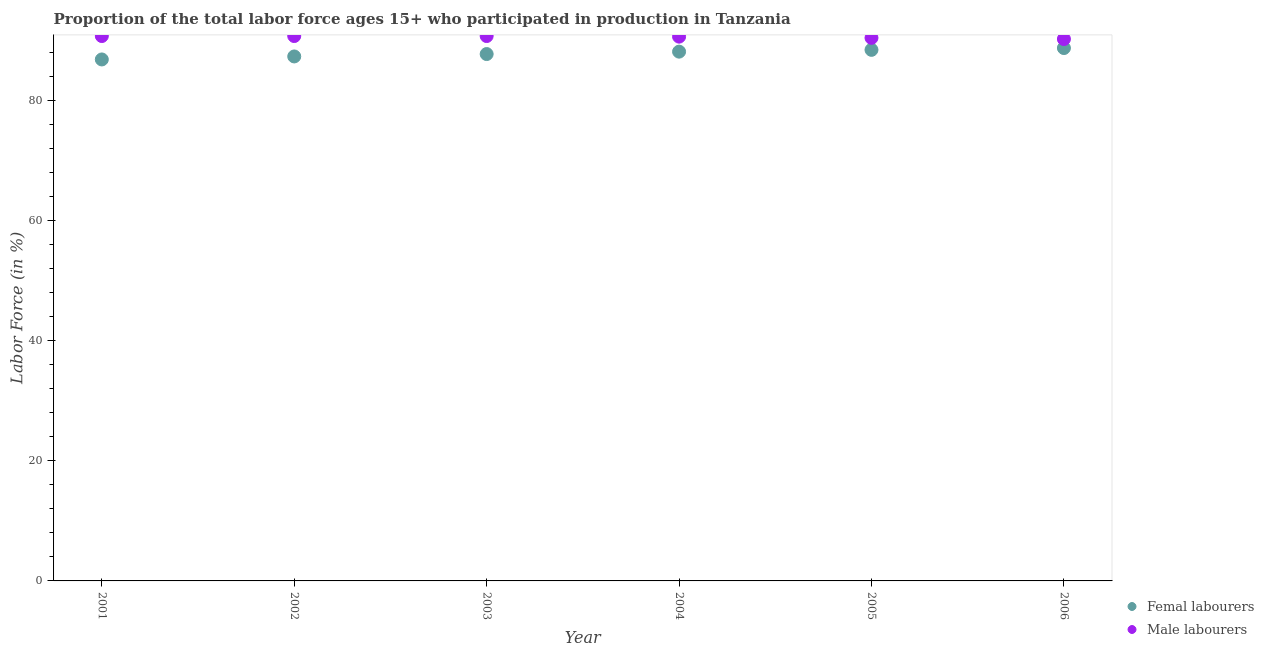Is the number of dotlines equal to the number of legend labels?
Make the answer very short. Yes. What is the percentage of female labor force in 2006?
Give a very brief answer. 88.8. Across all years, what is the maximum percentage of female labor force?
Your answer should be compact. 88.8. Across all years, what is the minimum percentage of male labour force?
Ensure brevity in your answer.  90.3. In which year was the percentage of female labor force minimum?
Provide a short and direct response. 2001. What is the total percentage of female labor force in the graph?
Your answer should be compact. 527.6. What is the difference between the percentage of female labor force in 2003 and that in 2004?
Give a very brief answer. -0.4. What is the difference between the percentage of female labor force in 2002 and the percentage of male labour force in 2005?
Provide a succinct answer. -3.1. What is the average percentage of female labor force per year?
Your response must be concise. 87.93. In the year 2003, what is the difference between the percentage of male labour force and percentage of female labor force?
Your answer should be compact. 3. In how many years, is the percentage of male labour force greater than 48 %?
Your answer should be very brief. 6. What is the ratio of the percentage of male labour force in 2002 to that in 2005?
Your answer should be very brief. 1. Is the percentage of female labor force in 2004 less than that in 2006?
Provide a short and direct response. Yes. Is the difference between the percentage of female labor force in 2004 and 2006 greater than the difference between the percentage of male labour force in 2004 and 2006?
Your response must be concise. No. What is the difference between the highest and the lowest percentage of female labor force?
Your response must be concise. 1.9. Does the percentage of female labor force monotonically increase over the years?
Your answer should be compact. Yes. Is the percentage of female labor force strictly greater than the percentage of male labour force over the years?
Offer a very short reply. No. How many dotlines are there?
Make the answer very short. 2. What is the difference between two consecutive major ticks on the Y-axis?
Your answer should be compact. 20. Does the graph contain grids?
Your response must be concise. No. How many legend labels are there?
Your answer should be very brief. 2. How are the legend labels stacked?
Provide a short and direct response. Vertical. What is the title of the graph?
Provide a short and direct response. Proportion of the total labor force ages 15+ who participated in production in Tanzania. Does "Banks" appear as one of the legend labels in the graph?
Your response must be concise. No. What is the Labor Force (in %) in Femal labourers in 2001?
Your response must be concise. 86.9. What is the Labor Force (in %) of Male labourers in 2001?
Your answer should be compact. 90.8. What is the Labor Force (in %) of Femal labourers in 2002?
Provide a succinct answer. 87.4. What is the Labor Force (in %) of Male labourers in 2002?
Offer a terse response. 90.8. What is the Labor Force (in %) of Femal labourers in 2003?
Ensure brevity in your answer.  87.8. What is the Labor Force (in %) in Male labourers in 2003?
Offer a very short reply. 90.8. What is the Labor Force (in %) in Femal labourers in 2004?
Offer a very short reply. 88.2. What is the Labor Force (in %) of Male labourers in 2004?
Offer a terse response. 90.7. What is the Labor Force (in %) of Femal labourers in 2005?
Offer a terse response. 88.5. What is the Labor Force (in %) of Male labourers in 2005?
Provide a succinct answer. 90.5. What is the Labor Force (in %) of Femal labourers in 2006?
Your answer should be compact. 88.8. What is the Labor Force (in %) in Male labourers in 2006?
Your response must be concise. 90.3. Across all years, what is the maximum Labor Force (in %) in Femal labourers?
Keep it short and to the point. 88.8. Across all years, what is the maximum Labor Force (in %) in Male labourers?
Keep it short and to the point. 90.8. Across all years, what is the minimum Labor Force (in %) in Femal labourers?
Your answer should be compact. 86.9. Across all years, what is the minimum Labor Force (in %) of Male labourers?
Your response must be concise. 90.3. What is the total Labor Force (in %) in Femal labourers in the graph?
Provide a succinct answer. 527.6. What is the total Labor Force (in %) of Male labourers in the graph?
Offer a very short reply. 543.9. What is the difference between the Labor Force (in %) in Male labourers in 2001 and that in 2002?
Your response must be concise. 0. What is the difference between the Labor Force (in %) in Femal labourers in 2001 and that in 2003?
Keep it short and to the point. -0.9. What is the difference between the Labor Force (in %) of Male labourers in 2001 and that in 2003?
Your answer should be very brief. 0. What is the difference between the Labor Force (in %) of Femal labourers in 2001 and that in 2004?
Give a very brief answer. -1.3. What is the difference between the Labor Force (in %) in Male labourers in 2001 and that in 2004?
Your answer should be very brief. 0.1. What is the difference between the Labor Force (in %) in Male labourers in 2001 and that in 2005?
Keep it short and to the point. 0.3. What is the difference between the Labor Force (in %) in Femal labourers in 2001 and that in 2006?
Provide a short and direct response. -1.9. What is the difference between the Labor Force (in %) of Male labourers in 2003 and that in 2004?
Your response must be concise. 0.1. What is the difference between the Labor Force (in %) in Male labourers in 2003 and that in 2005?
Ensure brevity in your answer.  0.3. What is the difference between the Labor Force (in %) in Femal labourers in 2003 and that in 2006?
Your answer should be compact. -1. What is the difference between the Labor Force (in %) of Male labourers in 2003 and that in 2006?
Your answer should be very brief. 0.5. What is the difference between the Labor Force (in %) in Male labourers in 2004 and that in 2005?
Provide a succinct answer. 0.2. What is the difference between the Labor Force (in %) of Femal labourers in 2001 and the Labor Force (in %) of Male labourers in 2002?
Your response must be concise. -3.9. What is the difference between the Labor Force (in %) in Femal labourers in 2001 and the Labor Force (in %) in Male labourers in 2003?
Provide a succinct answer. -3.9. What is the difference between the Labor Force (in %) in Femal labourers in 2002 and the Labor Force (in %) in Male labourers in 2005?
Provide a short and direct response. -3.1. What is the difference between the Labor Force (in %) of Femal labourers in 2002 and the Labor Force (in %) of Male labourers in 2006?
Provide a succinct answer. -2.9. What is the difference between the Labor Force (in %) in Femal labourers in 2004 and the Labor Force (in %) in Male labourers in 2005?
Your answer should be compact. -2.3. What is the difference between the Labor Force (in %) of Femal labourers in 2004 and the Labor Force (in %) of Male labourers in 2006?
Offer a very short reply. -2.1. What is the average Labor Force (in %) of Femal labourers per year?
Provide a succinct answer. 87.93. What is the average Labor Force (in %) of Male labourers per year?
Make the answer very short. 90.65. In the year 2001, what is the difference between the Labor Force (in %) of Femal labourers and Labor Force (in %) of Male labourers?
Provide a short and direct response. -3.9. In the year 2002, what is the difference between the Labor Force (in %) in Femal labourers and Labor Force (in %) in Male labourers?
Provide a succinct answer. -3.4. In the year 2004, what is the difference between the Labor Force (in %) of Femal labourers and Labor Force (in %) of Male labourers?
Offer a very short reply. -2.5. In the year 2006, what is the difference between the Labor Force (in %) of Femal labourers and Labor Force (in %) of Male labourers?
Make the answer very short. -1.5. What is the ratio of the Labor Force (in %) of Femal labourers in 2001 to that in 2002?
Keep it short and to the point. 0.99. What is the ratio of the Labor Force (in %) of Male labourers in 2001 to that in 2003?
Provide a short and direct response. 1. What is the ratio of the Labor Force (in %) in Femal labourers in 2001 to that in 2005?
Your answer should be very brief. 0.98. What is the ratio of the Labor Force (in %) in Femal labourers in 2001 to that in 2006?
Keep it short and to the point. 0.98. What is the ratio of the Labor Force (in %) of Male labourers in 2001 to that in 2006?
Give a very brief answer. 1.01. What is the ratio of the Labor Force (in %) of Femal labourers in 2002 to that in 2004?
Give a very brief answer. 0.99. What is the ratio of the Labor Force (in %) of Femal labourers in 2002 to that in 2005?
Make the answer very short. 0.99. What is the ratio of the Labor Force (in %) in Male labourers in 2002 to that in 2005?
Offer a terse response. 1. What is the ratio of the Labor Force (in %) in Femal labourers in 2002 to that in 2006?
Keep it short and to the point. 0.98. What is the ratio of the Labor Force (in %) of Male labourers in 2002 to that in 2006?
Your answer should be compact. 1.01. What is the ratio of the Labor Force (in %) of Femal labourers in 2003 to that in 2004?
Your answer should be compact. 1. What is the ratio of the Labor Force (in %) in Male labourers in 2003 to that in 2004?
Your answer should be compact. 1. What is the ratio of the Labor Force (in %) in Femal labourers in 2003 to that in 2005?
Give a very brief answer. 0.99. What is the ratio of the Labor Force (in %) of Male labourers in 2003 to that in 2005?
Your answer should be very brief. 1. What is the ratio of the Labor Force (in %) in Femal labourers in 2003 to that in 2006?
Provide a short and direct response. 0.99. What is the ratio of the Labor Force (in %) in Male labourers in 2003 to that in 2006?
Your response must be concise. 1.01. What is the ratio of the Labor Force (in %) of Male labourers in 2004 to that in 2006?
Offer a very short reply. 1. What is the ratio of the Labor Force (in %) of Femal labourers in 2005 to that in 2006?
Ensure brevity in your answer.  1. What is the ratio of the Labor Force (in %) in Male labourers in 2005 to that in 2006?
Offer a very short reply. 1. What is the difference between the highest and the second highest Labor Force (in %) in Femal labourers?
Offer a terse response. 0.3. What is the difference between the highest and the second highest Labor Force (in %) in Male labourers?
Keep it short and to the point. 0. What is the difference between the highest and the lowest Labor Force (in %) of Femal labourers?
Provide a short and direct response. 1.9. 